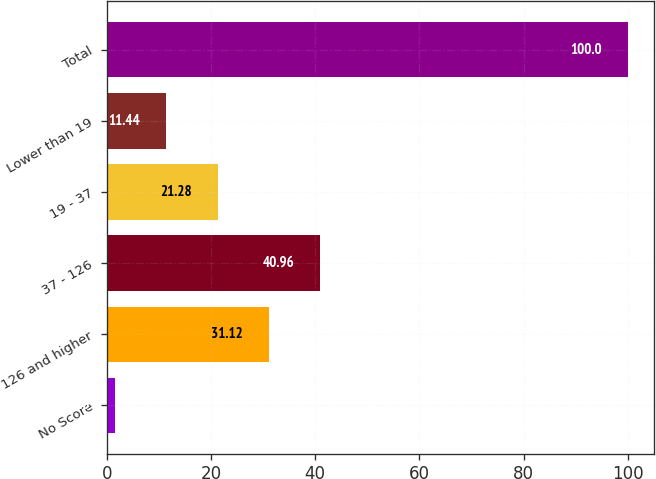Convert chart to OTSL. <chart><loc_0><loc_0><loc_500><loc_500><bar_chart><fcel>No Score<fcel>126 and higher<fcel>37 - 126<fcel>19 - 37<fcel>Lower than 19<fcel>Total<nl><fcel>1.6<fcel>31.12<fcel>40.96<fcel>21.28<fcel>11.44<fcel>100<nl></chart> 